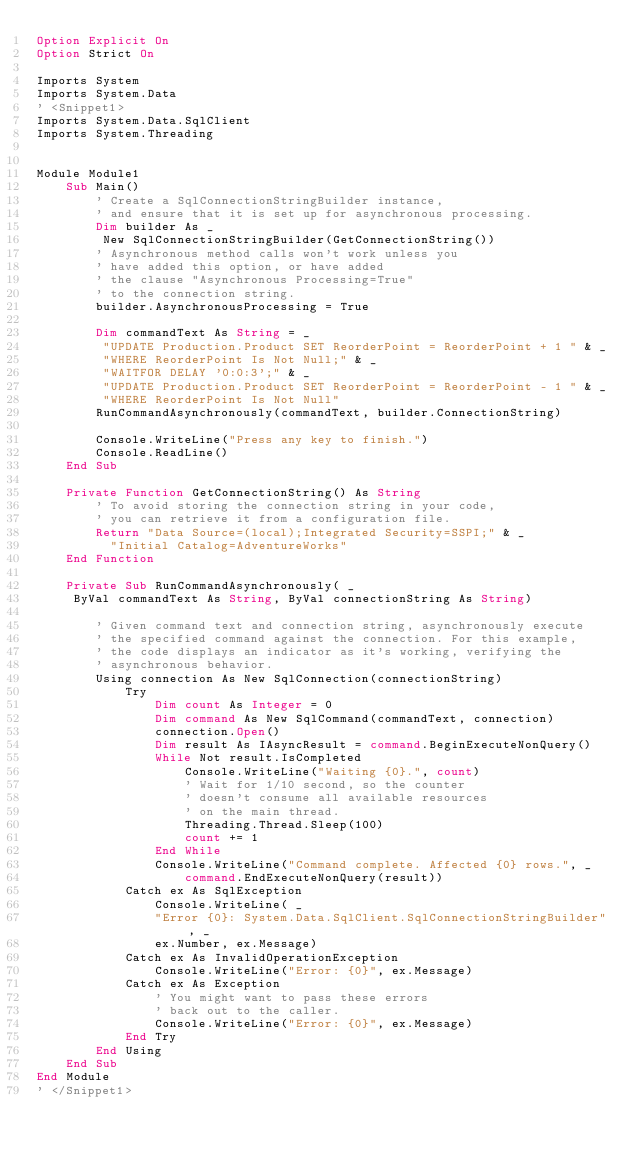Convert code to text. <code><loc_0><loc_0><loc_500><loc_500><_VisualBasic_>Option Explicit On
Option Strict On

Imports System
Imports System.Data
' <Snippet1>
Imports System.Data.SqlClient
Imports System.Threading


Module Module1
    Sub Main()
        ' Create a SqlConnectionStringBuilder instance, 
        ' and ensure that it is set up for asynchronous processing.
        Dim builder As _
         New SqlConnectionStringBuilder(GetConnectionString())
        ' Asynchronous method calls won't work unless you
        ' have added this option, or have added
        ' the clause "Asynchronous Processing=True"
        ' to the connection string.
        builder.AsynchronousProcessing = True

        Dim commandText As String = _
         "UPDATE Production.Product SET ReorderPoint = ReorderPoint + 1 " & _
         "WHERE ReorderPoint Is Not Null;" & _
         "WAITFOR DELAY '0:0:3';" & _
         "UPDATE Production.Product SET ReorderPoint = ReorderPoint - 1 " & _
         "WHERE ReorderPoint Is Not Null"
        RunCommandAsynchronously(commandText, builder.ConnectionString)

        Console.WriteLine("Press any key to finish.")
        Console.ReadLine()
    End Sub

    Private Function GetConnectionString() As String
        ' To avoid storing the connection string in your code,
        ' you can retrieve it from a configuration file. 
        Return "Data Source=(local);Integrated Security=SSPI;" & _
          "Initial Catalog=AdventureWorks"
    End Function

    Private Sub RunCommandAsynchronously( _
     ByVal commandText As String, ByVal connectionString As String)

        ' Given command text and connection string, asynchronously execute
        ' the specified command against the connection. For this example,
        ' the code displays an indicator as it's working, verifying the 
        ' asynchronous behavior. 
        Using connection As New SqlConnection(connectionString)
            Try
                Dim count As Integer = 0
                Dim command As New SqlCommand(commandText, connection)
                connection.Open()
                Dim result As IAsyncResult = command.BeginExecuteNonQuery()
                While Not result.IsCompleted
                    Console.WriteLine("Waiting {0}.", count)
                    ' Wait for 1/10 second, so the counter
                    ' doesn't consume all available resources 
                    ' on the main thread.
                    Threading.Thread.Sleep(100)
                    count += 1
                End While
                Console.WriteLine("Command complete. Affected {0} rows.", _
                    command.EndExecuteNonQuery(result))
            Catch ex As SqlException
                Console.WriteLine( _
                "Error {0}: System.Data.SqlClient.SqlConnectionStringBuilder", _
                ex.Number, ex.Message)
            Catch ex As InvalidOperationException
                Console.WriteLine("Error: {0}", ex.Message)
            Catch ex As Exception
                ' You might want to pass these errors
                ' back out to the caller.
                Console.WriteLine("Error: {0}", ex.Message)
            End Try
        End Using
    End Sub
End Module
' </Snippet1>

</code> 